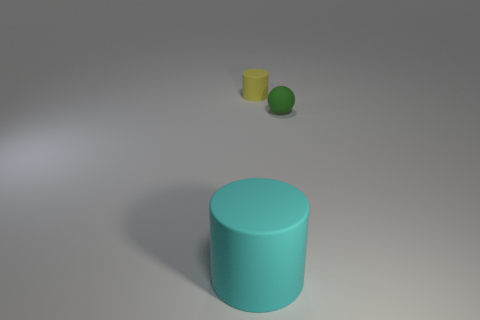Is the color of the large cylinder the same as the small matte object to the left of the small green thing? no 